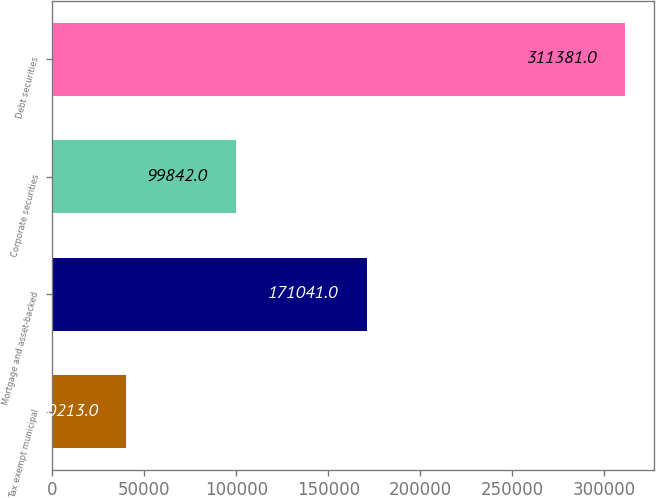Convert chart to OTSL. <chart><loc_0><loc_0><loc_500><loc_500><bar_chart><fcel>Tax exempt municipal<fcel>Mortgage and asset-backed<fcel>Corporate securities<fcel>Debt securities<nl><fcel>40213<fcel>171041<fcel>99842<fcel>311381<nl></chart> 